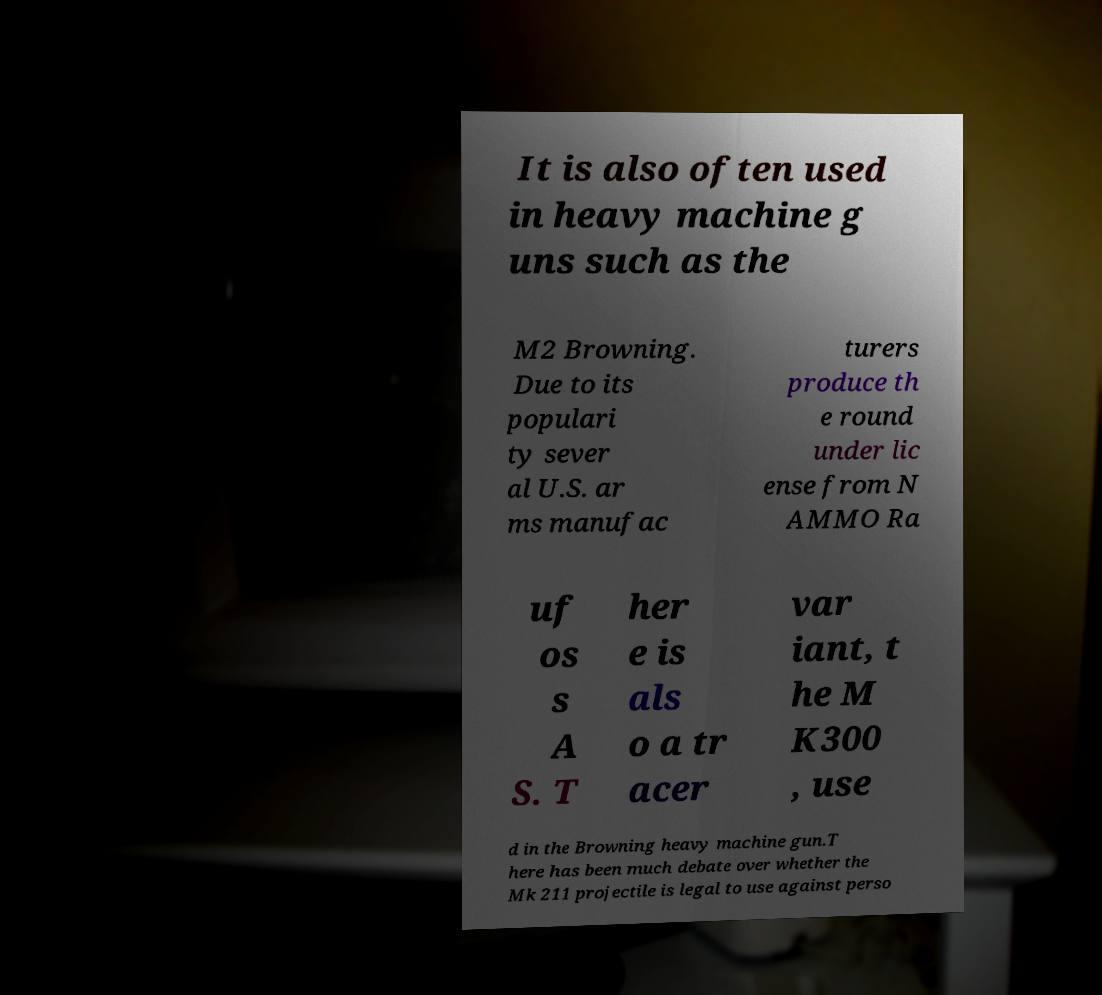Can you accurately transcribe the text from the provided image for me? It is also often used in heavy machine g uns such as the M2 Browning. Due to its populari ty sever al U.S. ar ms manufac turers produce th e round under lic ense from N AMMO Ra uf os s A S. T her e is als o a tr acer var iant, t he M K300 , use d in the Browning heavy machine gun.T here has been much debate over whether the Mk 211 projectile is legal to use against perso 